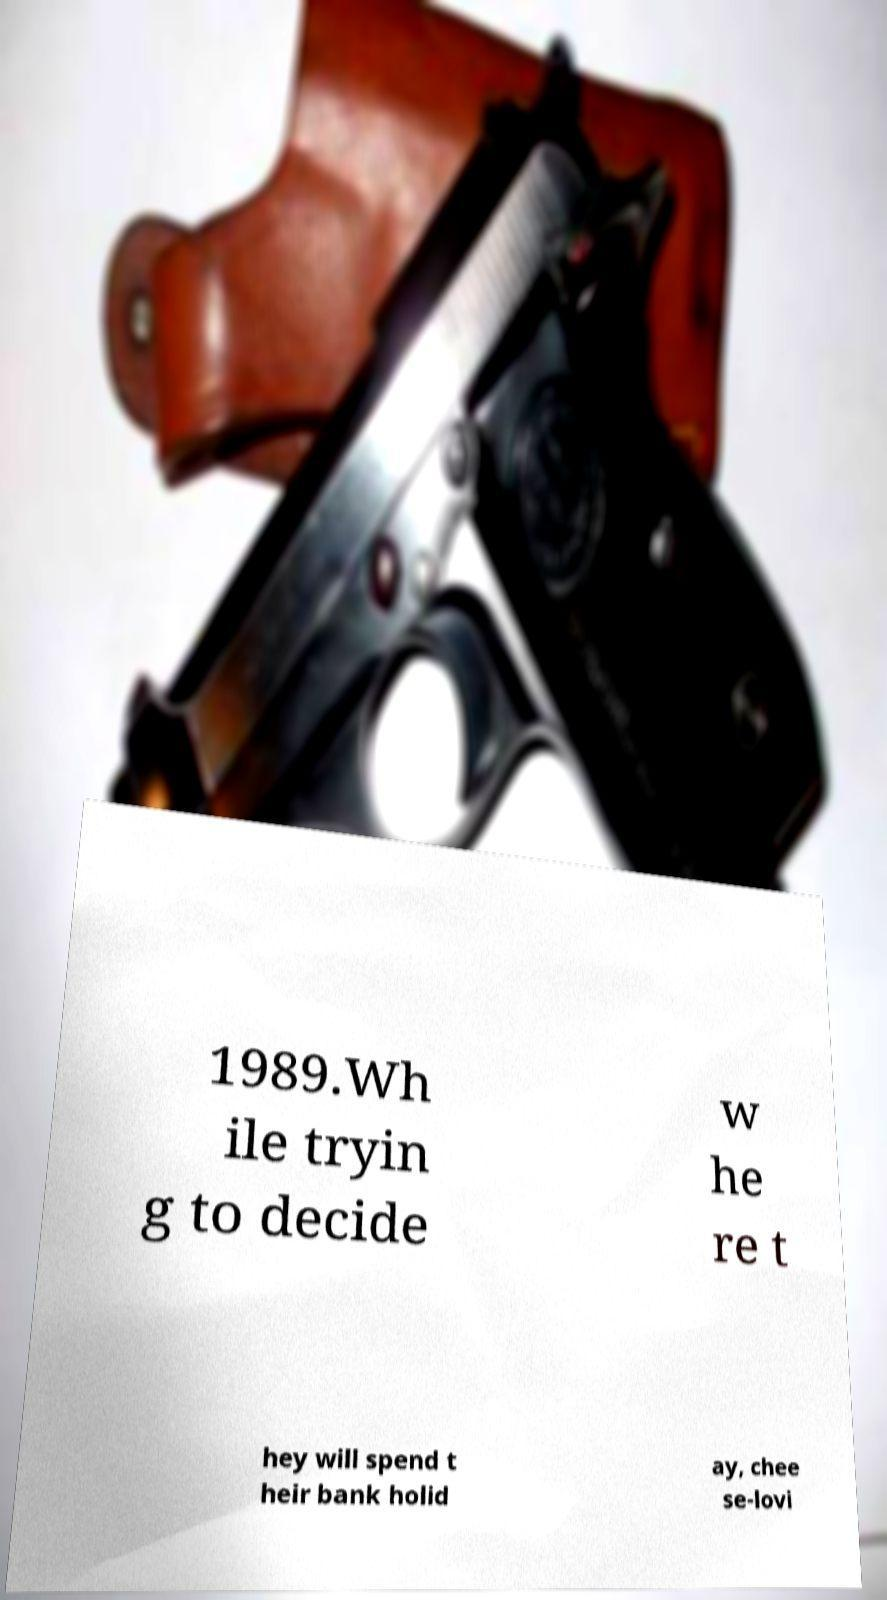I need the written content from this picture converted into text. Can you do that? 1989.Wh ile tryin g to decide w he re t hey will spend t heir bank holid ay, chee se-lovi 